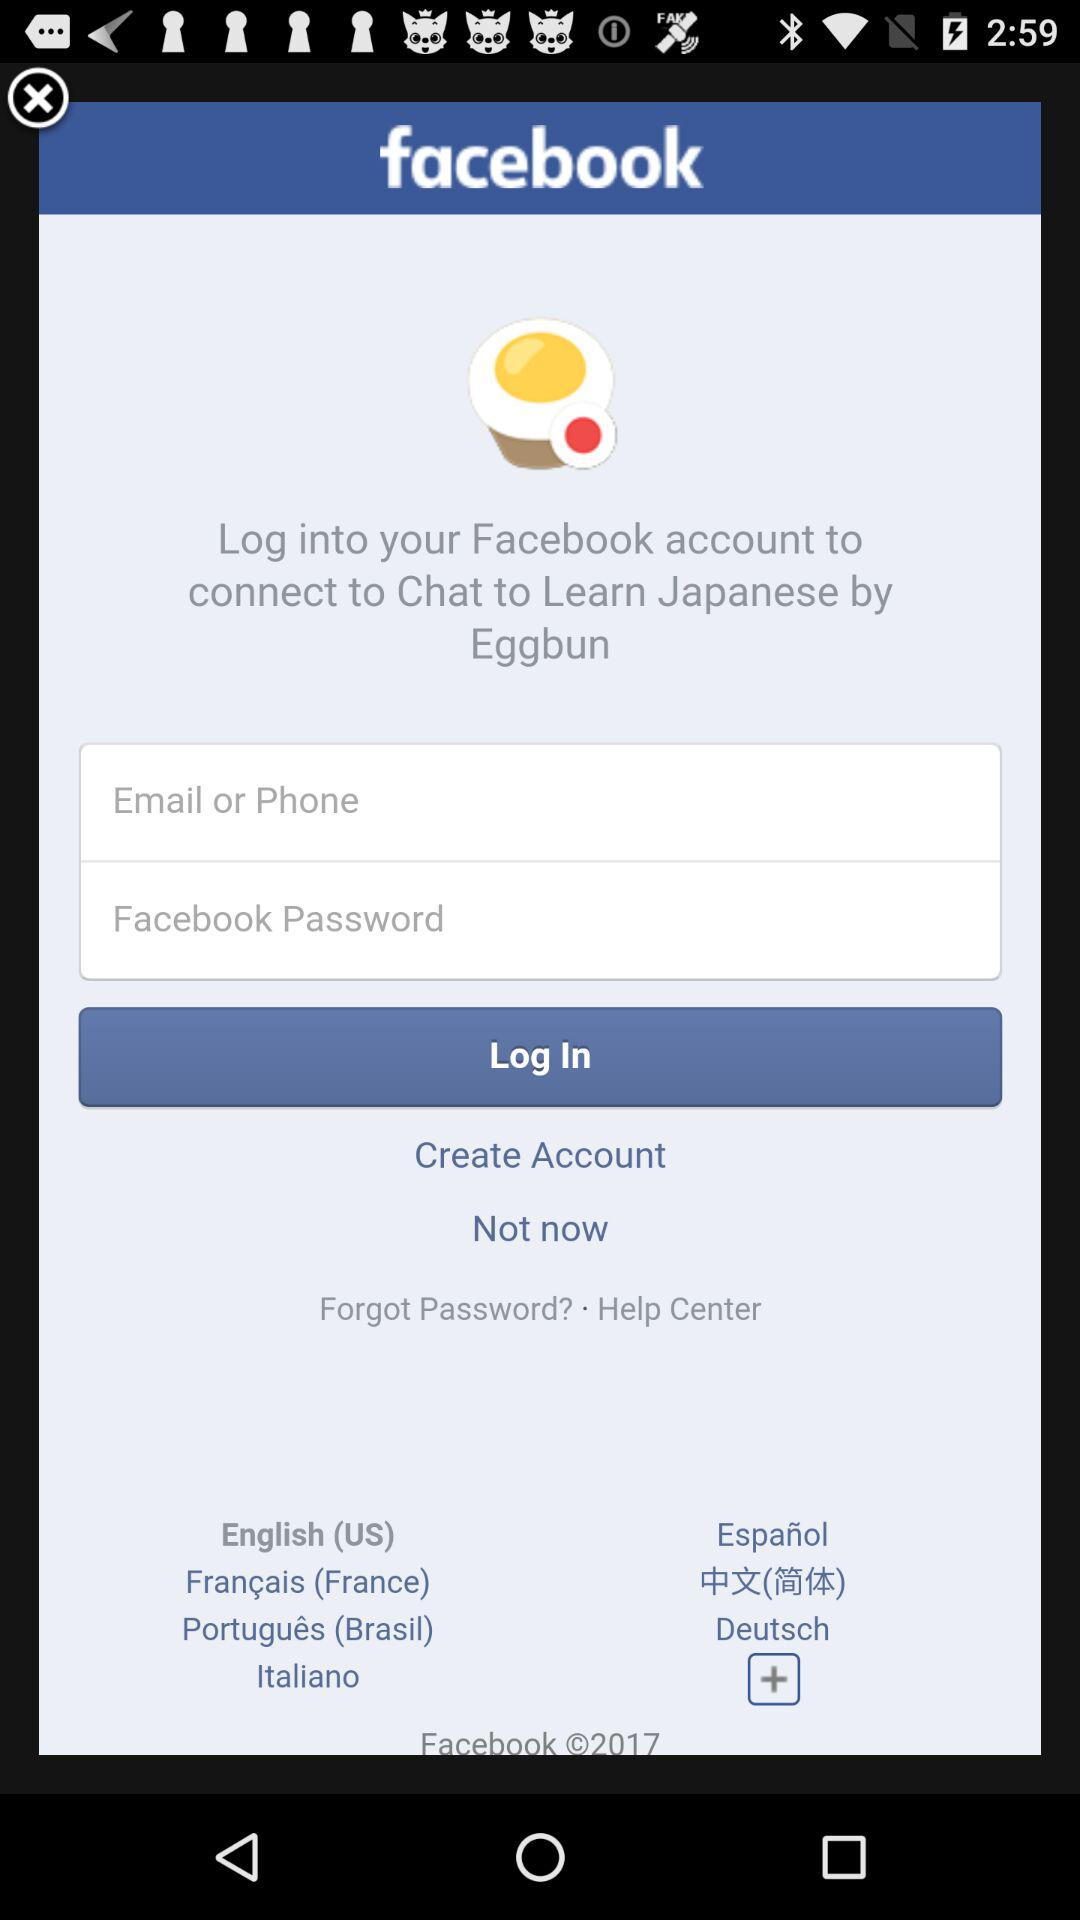How many input fields are there for logging into Facebook?
Answer the question using a single word or phrase. 2 